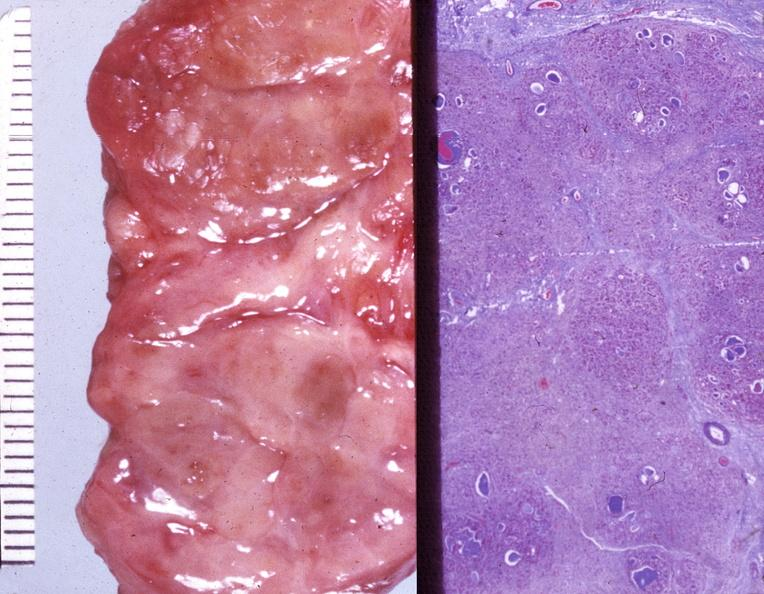where does this belong to?
Answer the question using a single word or phrase. Endocrine system 